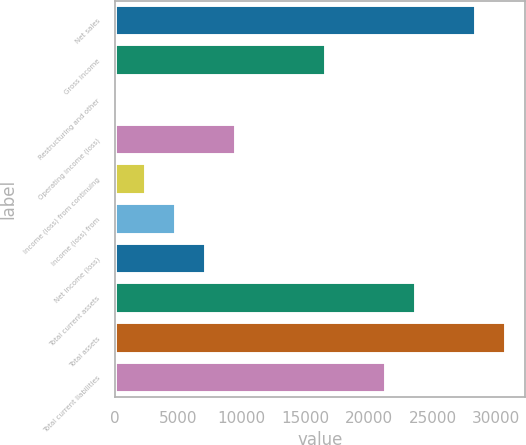Convert chart to OTSL. <chart><loc_0><loc_0><loc_500><loc_500><bar_chart><fcel>Net sales<fcel>Gross income<fcel>Restructuring and other<fcel>Operating income (loss)<fcel>Income (loss) from continuing<fcel>Income (loss) from<fcel>Net income (loss)<fcel>Total current assets<fcel>Total assets<fcel>Total current liabilities<nl><fcel>28407.2<fcel>16609.2<fcel>92<fcel>9530.4<fcel>2451.6<fcel>4811.2<fcel>7170.8<fcel>23688<fcel>30766.8<fcel>21328.4<nl></chart> 